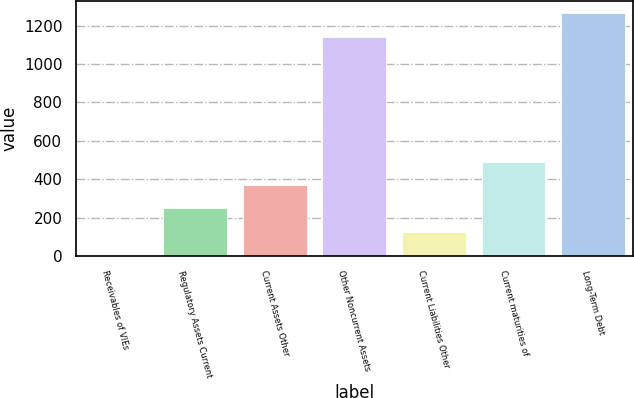Convert chart. <chart><loc_0><loc_0><loc_500><loc_500><bar_chart><fcel>Receivables of VIEs<fcel>Regulatory Assets Current<fcel>Current Assets Other<fcel>Other Noncurrent Assets<fcel>Current Liabilities Other<fcel>Current maturities of<fcel>Long-Term Debt<nl><fcel>6<fcel>248.2<fcel>369.3<fcel>1142<fcel>127.1<fcel>490.4<fcel>1263.1<nl></chart> 